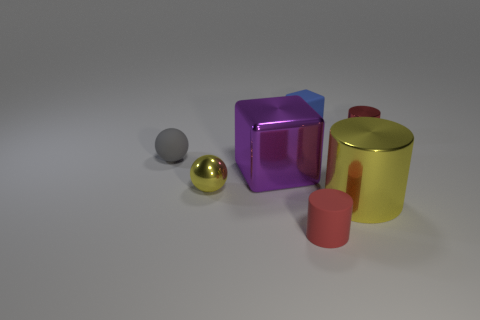What number of things are either rubber things that are in front of the small blue thing or small cylinders to the left of the blue matte cube?
Offer a terse response. 2. There is a tiny object that is right of the large cylinder; what is its color?
Give a very brief answer. Red. Are there any small blue objects that are on the right side of the cylinder behind the yellow cylinder?
Offer a very short reply. No. Are there fewer large shiny things than shiny balls?
Provide a succinct answer. No. What material is the tiny red cylinder behind the tiny metallic object that is on the left side of the small red matte object made of?
Offer a terse response. Metal. Does the blue matte thing have the same size as the purple metal object?
Ensure brevity in your answer.  No. How many objects are either cyan rubber objects or tiny red things?
Your response must be concise. 2. There is a matte object that is both behind the big purple cube and left of the tiny rubber block; how big is it?
Your answer should be compact. Small. Is the number of big purple cubes in front of the tiny red matte object less than the number of rubber cylinders?
Keep it short and to the point. Yes. What is the shape of the small red thing that is made of the same material as the tiny yellow thing?
Keep it short and to the point. Cylinder. 